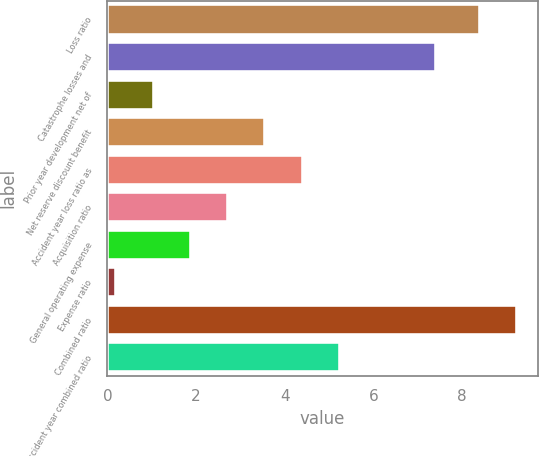Convert chart to OTSL. <chart><loc_0><loc_0><loc_500><loc_500><bar_chart><fcel>Loss ratio<fcel>Catastrophe losses and<fcel>Prior year development net of<fcel>Net reserve discount benefit<fcel>Accident year loss ratio as<fcel>Acquisition ratio<fcel>General operating expense<fcel>Expense ratio<fcel>Combined ratio<fcel>Accident year combined ratio<nl><fcel>8.4<fcel>7.4<fcel>1.04<fcel>3.56<fcel>4.4<fcel>2.72<fcel>1.88<fcel>0.2<fcel>9.24<fcel>5.24<nl></chart> 